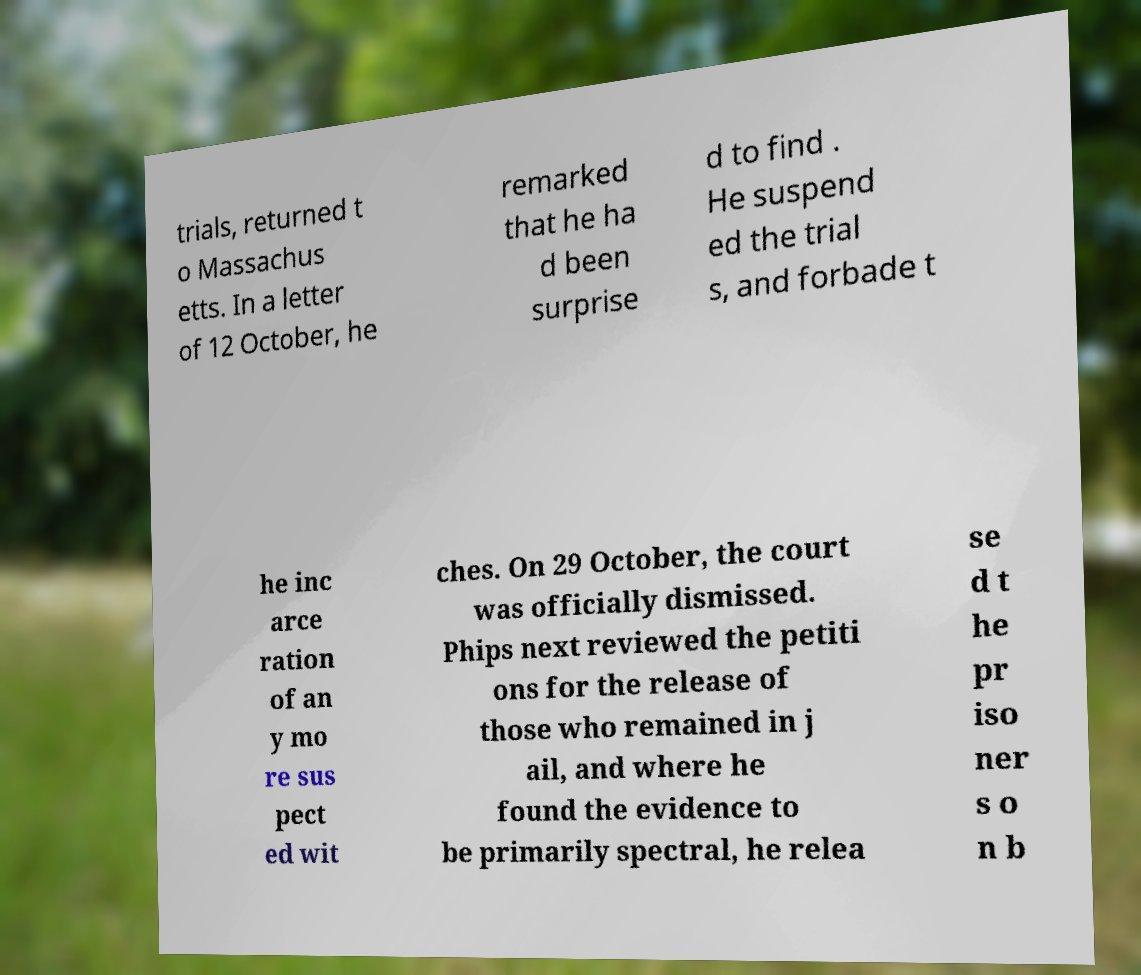There's text embedded in this image that I need extracted. Can you transcribe it verbatim? trials, returned t o Massachus etts. In a letter of 12 October, he remarked that he ha d been surprise d to find . He suspend ed the trial s, and forbade t he inc arce ration of an y mo re sus pect ed wit ches. On 29 October, the court was officially dismissed. Phips next reviewed the petiti ons for the release of those who remained in j ail, and where he found the evidence to be primarily spectral, he relea se d t he pr iso ner s o n b 